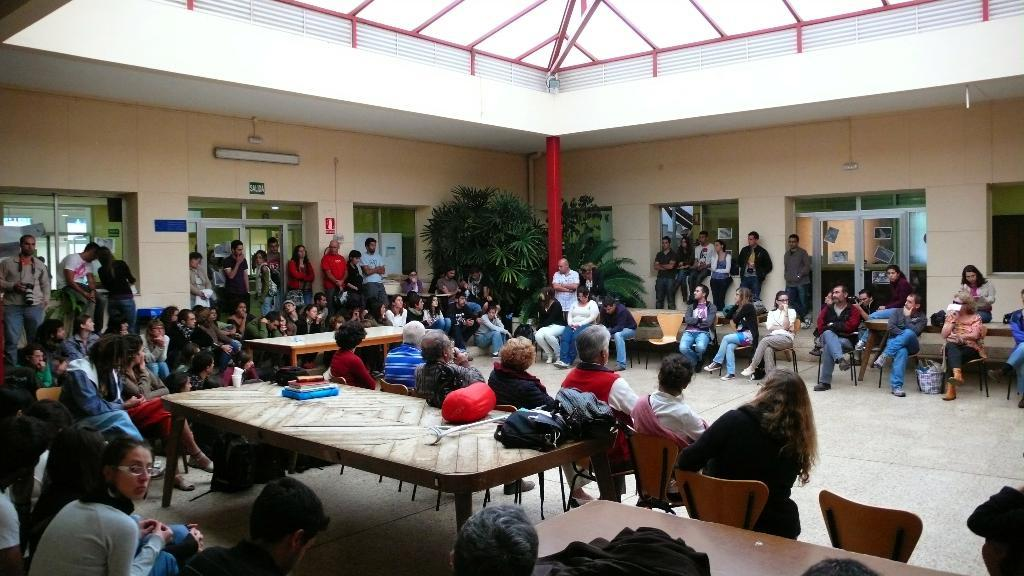How many people are in the image? The number of people in the image is not specified, but there are people present. What positions are the people in? Some people are sitting on chairs, while others are sitting on the floor. What is the location of the scene in the image? The setting appears to be in a hall. Are there any plants visible in the image? Yes, there are plants located at the edge of the room. What type of tree can be seen in the image? There is no tree present in the image; it features people sitting in a hall with plants at the edge of the room. Where is the sink located in the image? There is no sink present in the image. 